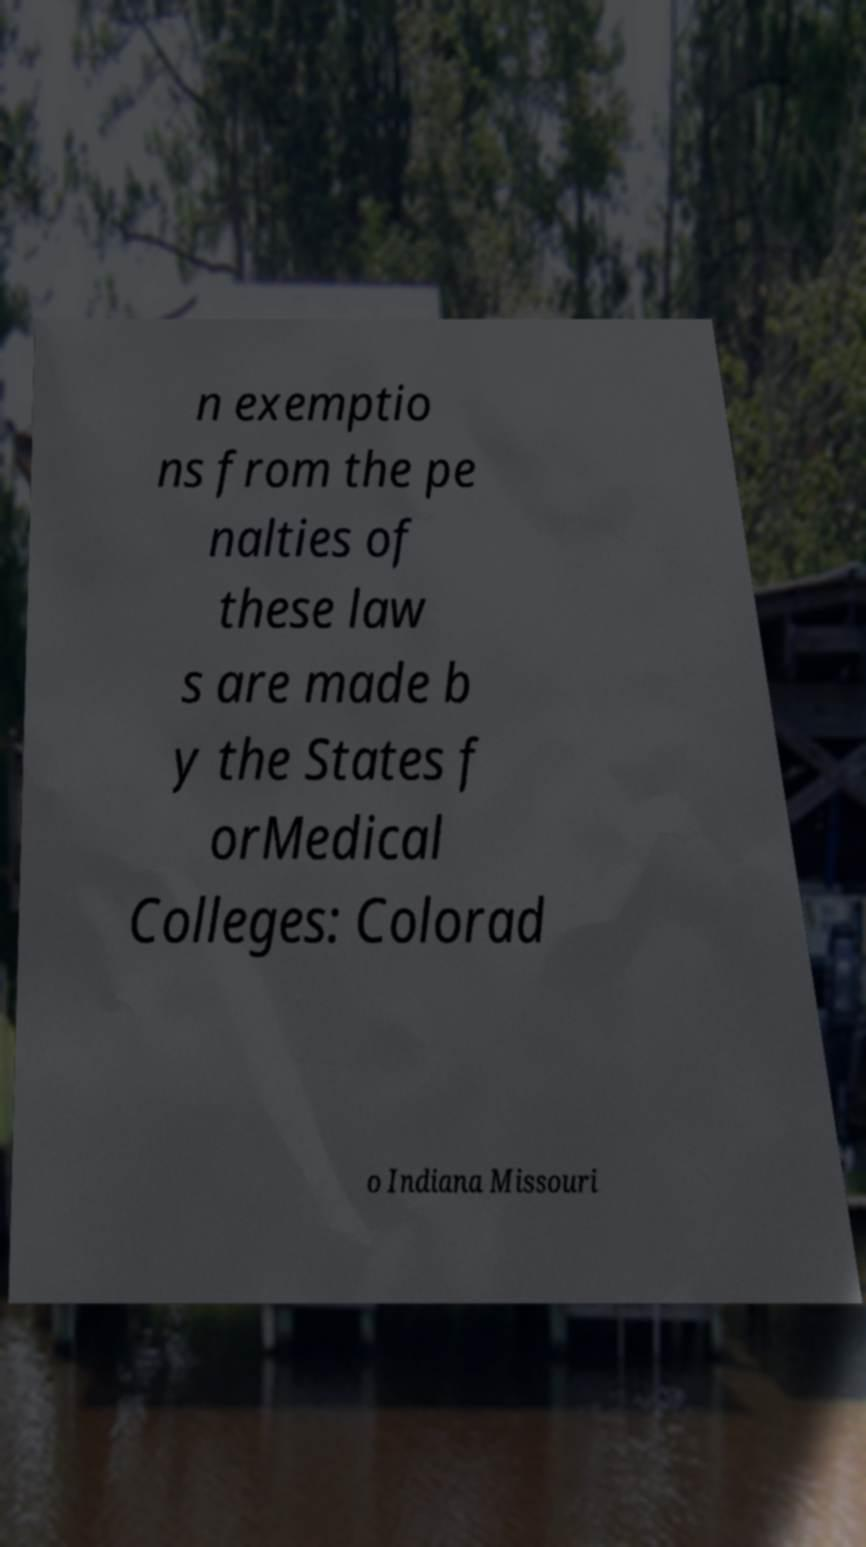Please identify and transcribe the text found in this image. n exemptio ns from the pe nalties of these law s are made b y the States f orMedical Colleges: Colorad o Indiana Missouri 